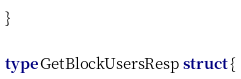Convert code to text. <code><loc_0><loc_0><loc_500><loc_500><_Go_>}

type GetBlockUsersResp struct {</code> 